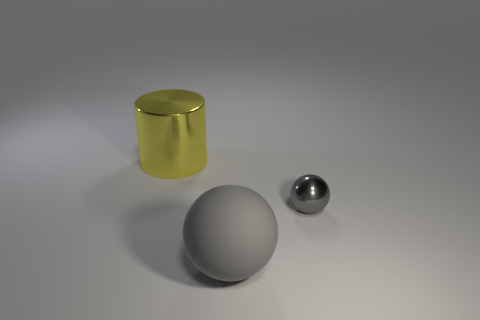What materials are depicted in the objects shown in the image? The image showcases objects that appear to be made of different materials. The large object in the background possesses a shiny, reflective surface and a golden tint which suggests that it may be made of metal or coated with a metallic paint. The sphere in the middle has a matte finish, indicative of rubber or a similar material. Lastly, the smaller object in front appears to be made of a polished metal, likely steel or aluminum, due to its shiny, reflective surface. 